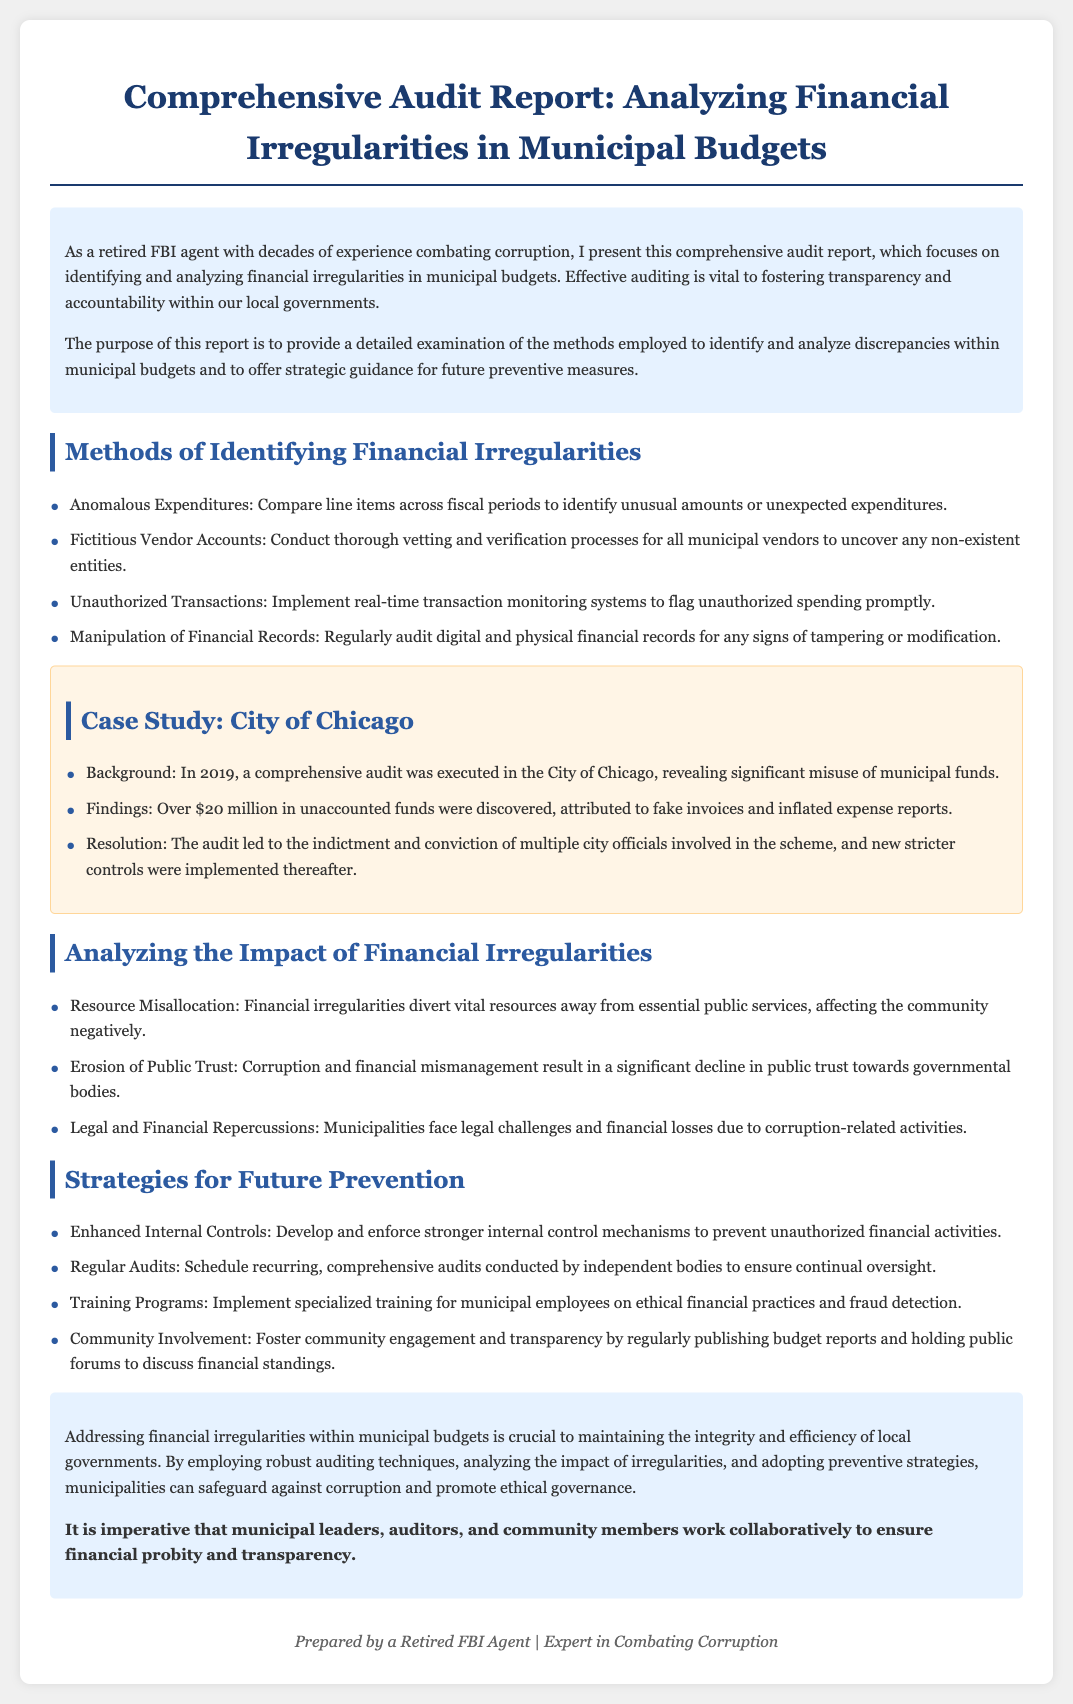what is the main purpose of the report? The report provides a detailed examination of methods employed to identify and analyze discrepancies within municipal budgets and offers strategic guidance for future preventive measures.
Answer: To identify and analyze discrepancies what amount of unaccounted funds was discovered in the City of Chicago audit? The audit revealed significant misuse of municipal funds, with over $20 million in unaccounted funds discovered attributed to fake invoices and inflated expense reports.
Answer: Over $20 million name one of the methods for identifying financial irregularities. The report lists several methods to identify financial irregularities, including comparing line items across fiscal periods to identify unusual amounts.
Answer: Anomalous Expenditures what negative impact do financial irregularities have on public trust? Financial irregularities lead to a significant decline in public trust towards governmental bodies.
Answer: Erosion of Public Trust how many strategies for future prevention are mentioned in the report? The report outlines four strategies for future prevention of financial irregularities within municipal budgets.
Answer: Four what is one recommended strategy for preventing financial irregularities? One strategy mentioned in the report is to develop and enforce stronger internal control mechanisms.
Answer: Enhanced Internal Controls who conducted the audit in the City of Chicago? The audit was executed in the City of Chicago in 2019, revealing significant misuse of municipal funds.
Answer: An independent body what is emphasized as crucial to maintaining the integrity of local governments? The report stresses that addressing financial irregularities within municipal budgets is crucial to maintaining integrity and efficiency.
Answer: Addressing financial irregularities what type of report is presented in this document? The document presents a comprehensive audit report specifically analyzing financial irregularities in municipal budgets.
Answer: Audit Report 